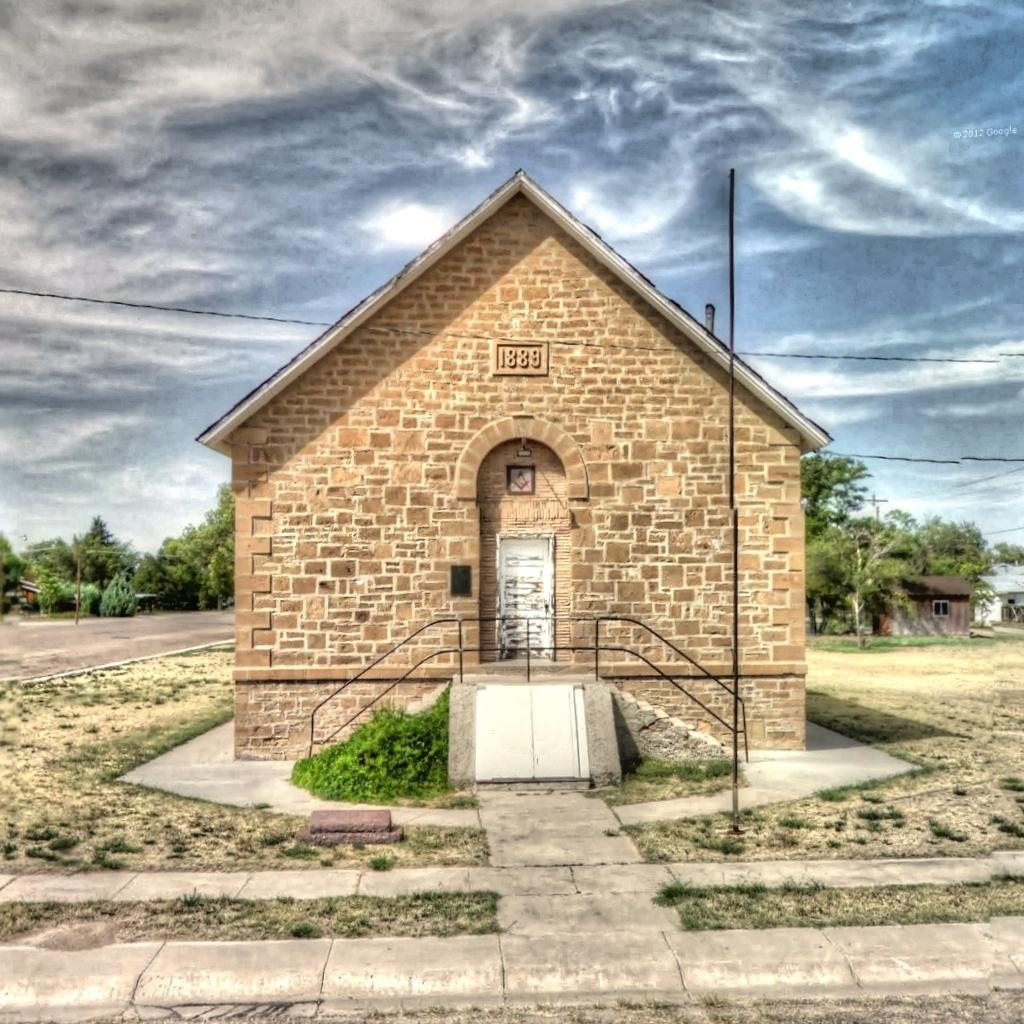What type of structures can be seen in the image? There are buildings in the image. What type of architectural feature is present in the image? Railings are present in the image. What type of vegetation is visible in the image? Shrubs and trees are present in the image. What type of infrastructure is visible in the image? Cables are visible in the image. What is visible in the background of the image? The sky is visible in the background of the image. What can be seen in the sky? Clouds are present in the sky. What type of lettuce is being used as a decoration in the image? There is no lettuce present in the image. What type of activity is taking place in the image? The image does not depict any specific activity; it shows buildings, railings, shrubs, trees, cables, and the sky. What type of juice is being served in the image? There is no juice present in the image. 